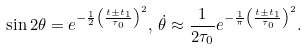Convert formula to latex. <formula><loc_0><loc_0><loc_500><loc_500>\sin 2 \theta = e ^ { - \frac { 1 } { 2 } \left ( \frac { t \pm t _ { 1 } } { \tau _ { 0 } } \right ) ^ { 2 } } , \, \dot { \theta } \approx \frac { 1 } { 2 \tau _ { 0 } } e ^ { - \frac { 1 } { \pi } \left ( \frac { t \pm t _ { 1 } } { \tau _ { 0 } } \right ) ^ { 2 } } .</formula> 